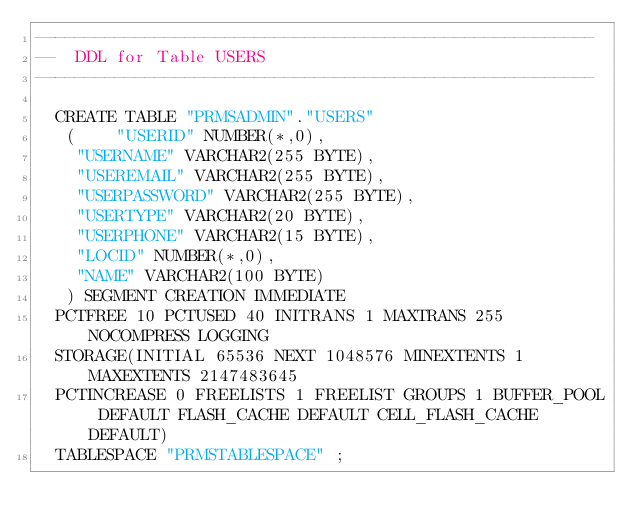Convert code to text. <code><loc_0><loc_0><loc_500><loc_500><_SQL_>--------------------------------------------------------
--  DDL for Table USERS
--------------------------------------------------------

  CREATE TABLE "PRMSADMIN"."USERS" 
   (	"USERID" NUMBER(*,0), 
	"USERNAME" VARCHAR2(255 BYTE), 
	"USEREMAIL" VARCHAR2(255 BYTE), 
	"USERPASSWORD" VARCHAR2(255 BYTE), 
	"USERTYPE" VARCHAR2(20 BYTE), 
	"USERPHONE" VARCHAR2(15 BYTE), 
	"LOCID" NUMBER(*,0), 
	"NAME" VARCHAR2(100 BYTE)
   ) SEGMENT CREATION IMMEDIATE 
  PCTFREE 10 PCTUSED 40 INITRANS 1 MAXTRANS 255 NOCOMPRESS LOGGING
  STORAGE(INITIAL 65536 NEXT 1048576 MINEXTENTS 1 MAXEXTENTS 2147483645
  PCTINCREASE 0 FREELISTS 1 FREELIST GROUPS 1 BUFFER_POOL DEFAULT FLASH_CACHE DEFAULT CELL_FLASH_CACHE DEFAULT)
  TABLESPACE "PRMSTABLESPACE" ;
</code> 